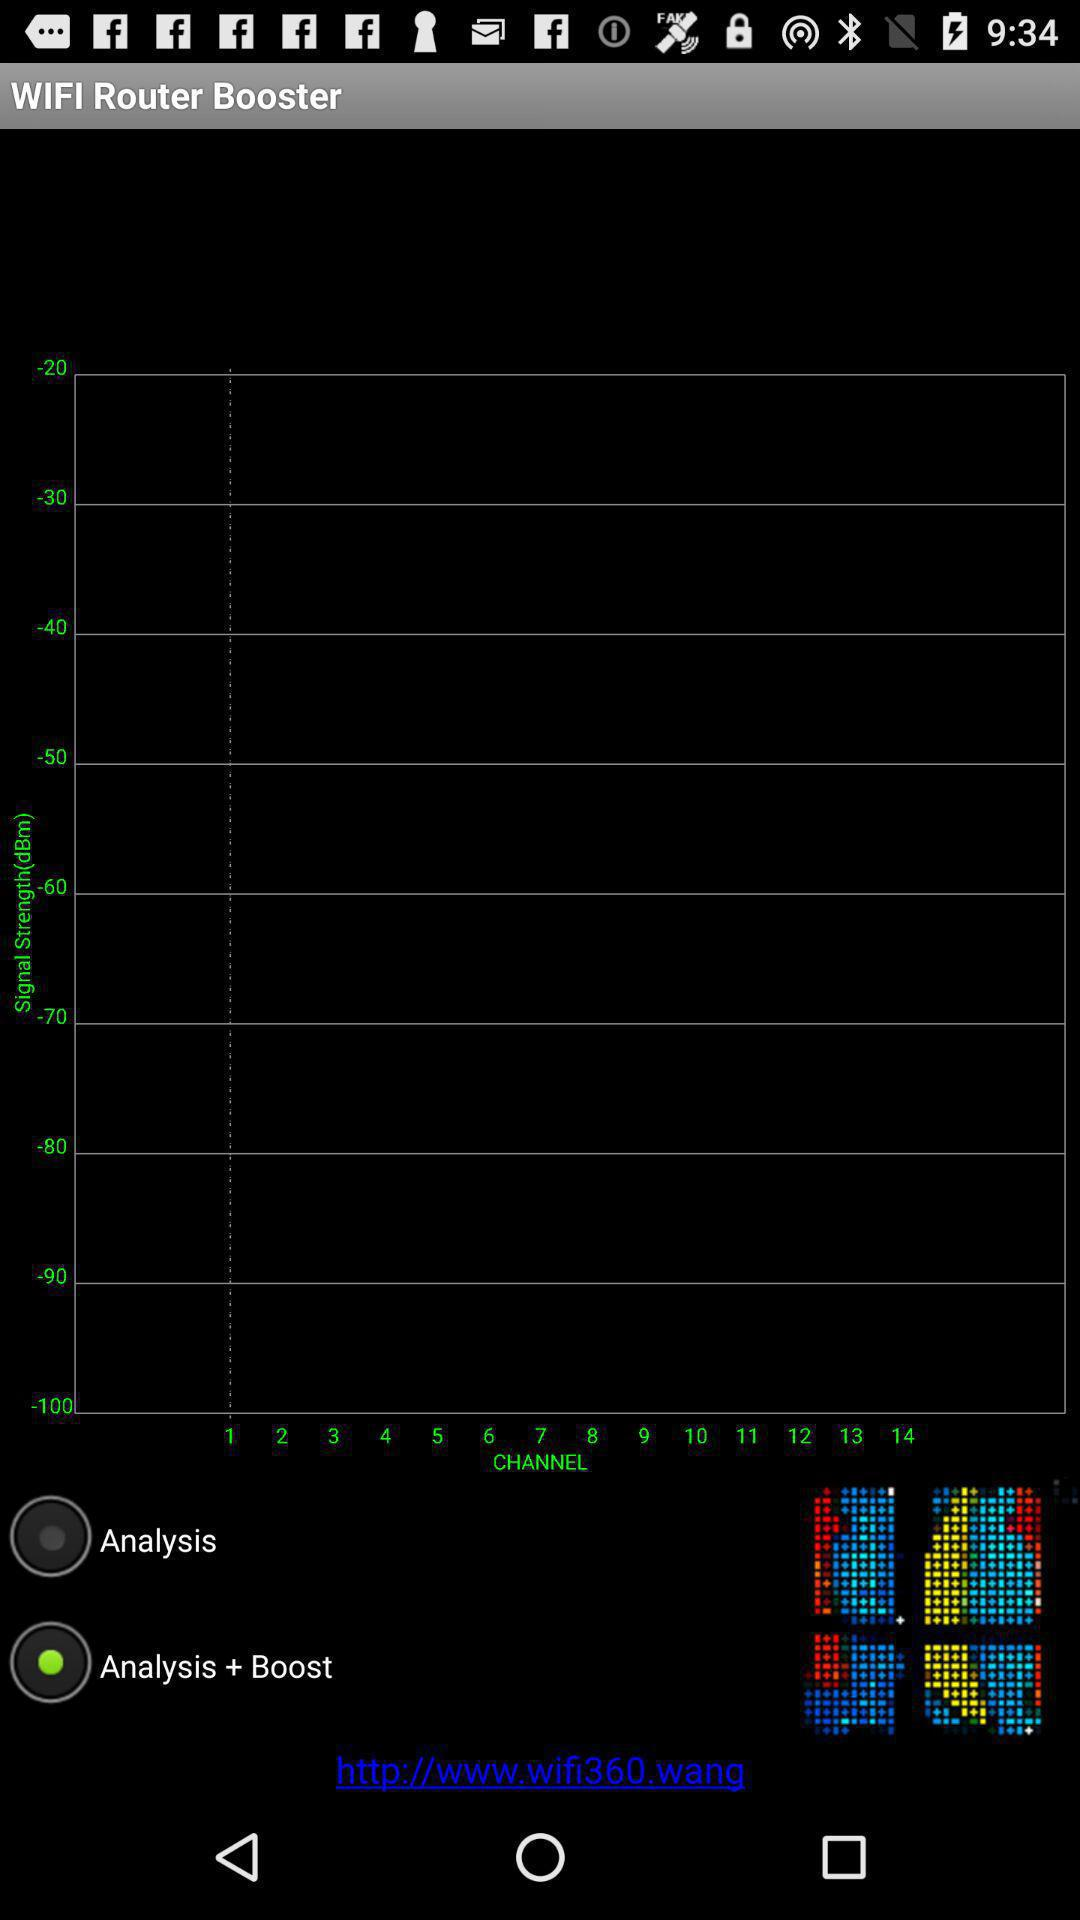Which option is selected? The selected option is "Analysis + Boost". 